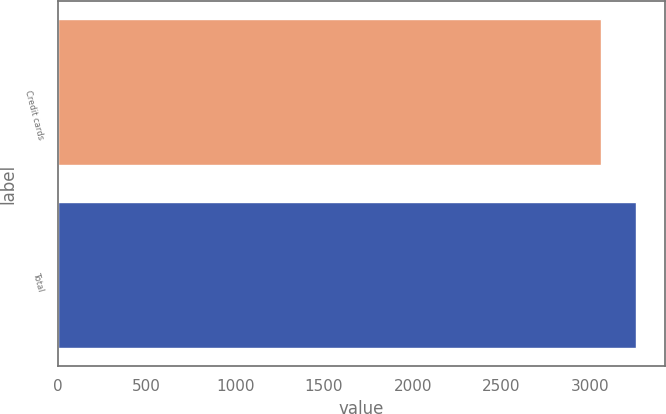<chart> <loc_0><loc_0><loc_500><loc_500><bar_chart><fcel>Credit cards<fcel>Total<nl><fcel>3058<fcel>3257<nl></chart> 